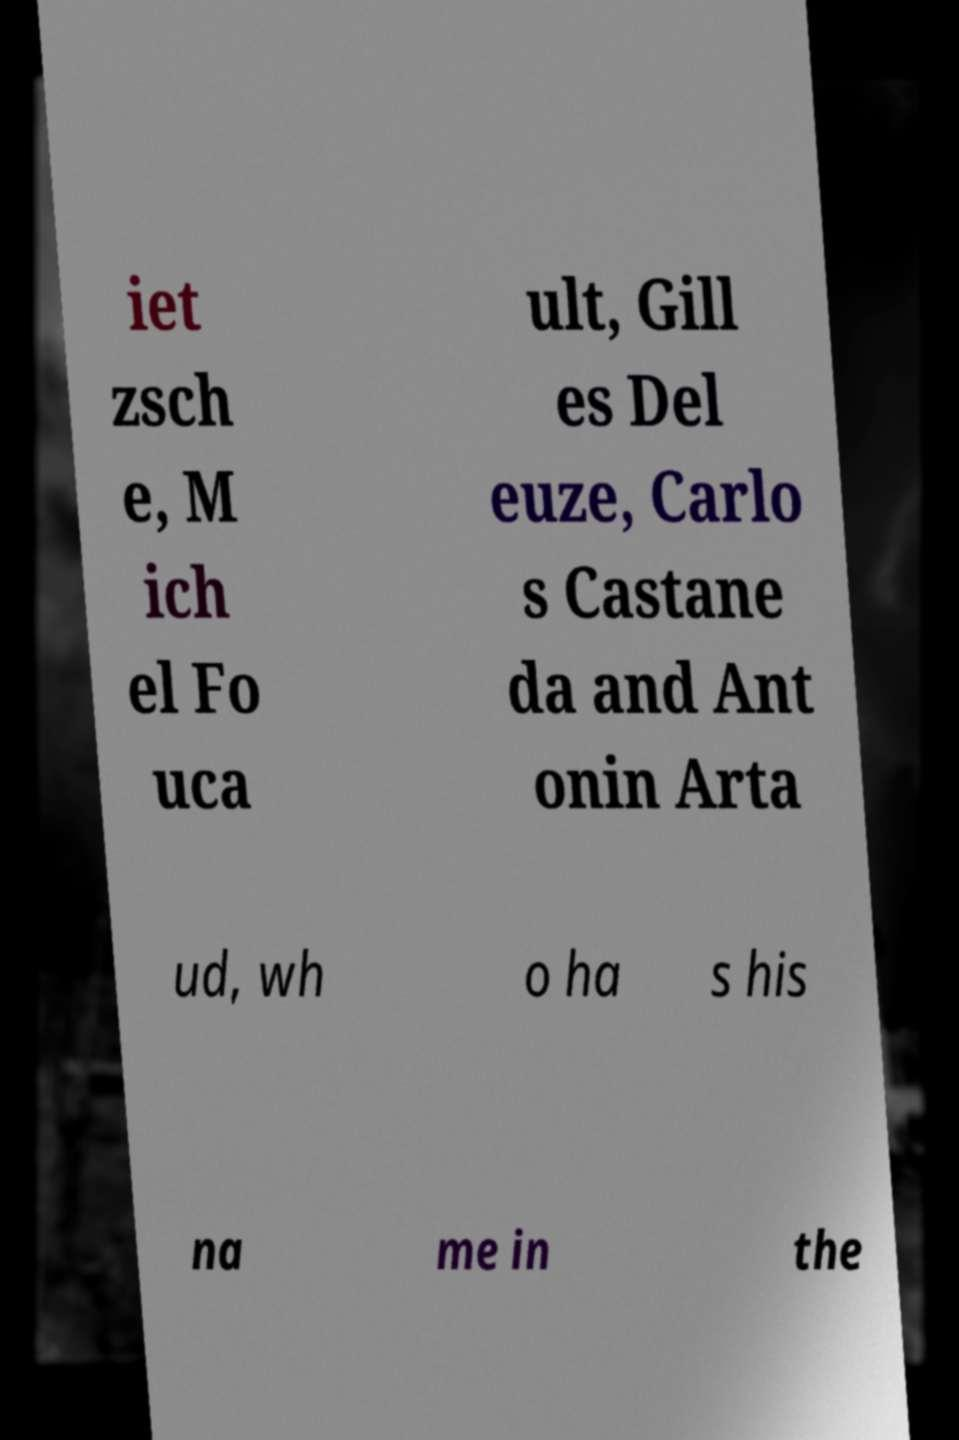Can you accurately transcribe the text from the provided image for me? iet zsch e, M ich el Fo uca ult, Gill es Del euze, Carlo s Castane da and Ant onin Arta ud, wh o ha s his na me in the 